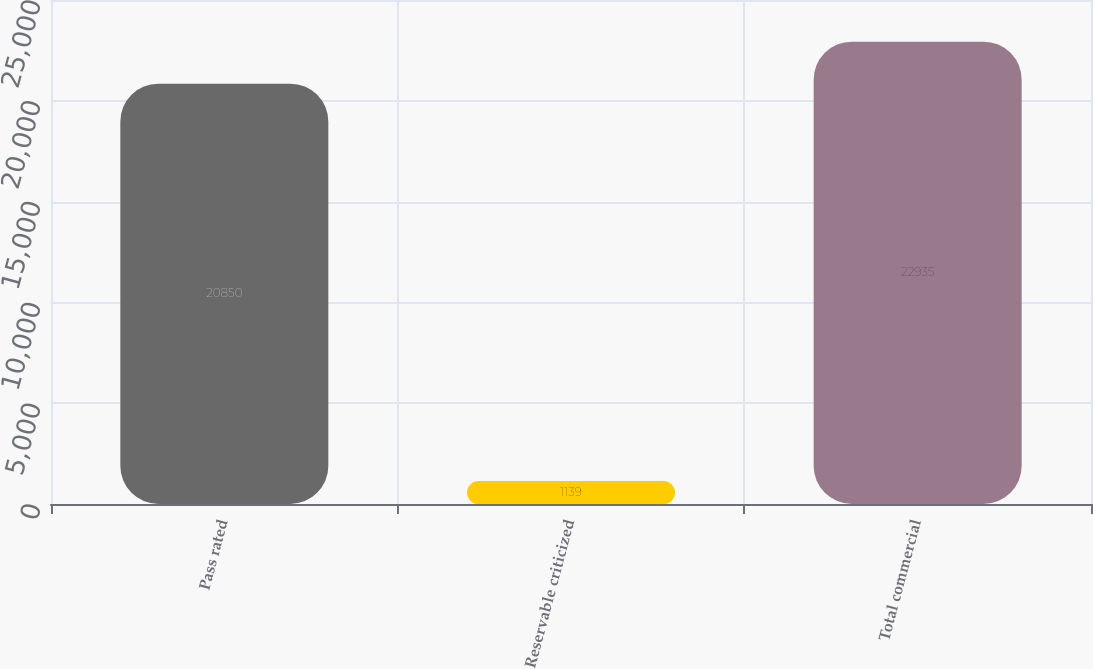Convert chart to OTSL. <chart><loc_0><loc_0><loc_500><loc_500><bar_chart><fcel>Pass rated<fcel>Reservable criticized<fcel>Total commercial<nl><fcel>20850<fcel>1139<fcel>22935<nl></chart> 